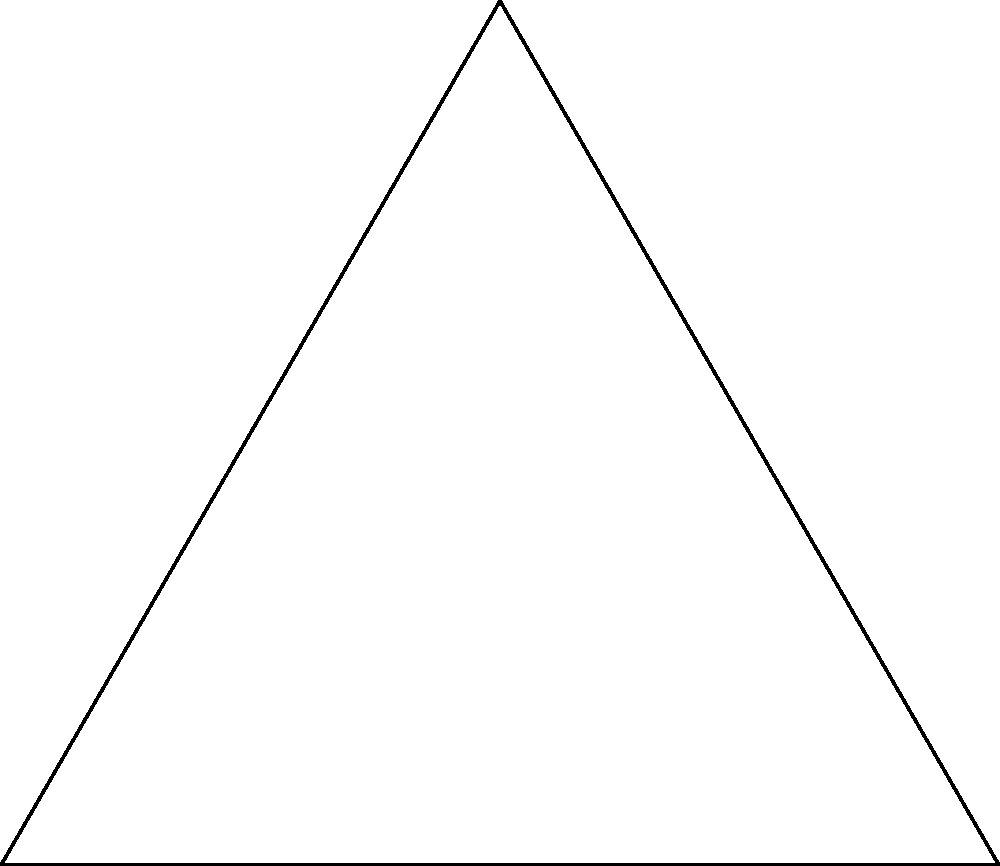In an aerial photograph of a historical Iranian airport, two runways intersect at point O. Runway 1 extends from O to A, and Runway 2 extends from O to B. If OA = 4 km, OB = 4 km, and AB = 4 km, what is the angle $\theta$ (in degrees) between the two runways? To find the angle between the two runways, we can use the cosine law. The cosine law states that in a triangle with sides a, b, and c, and an angle C opposite side c:

$$c^2 = a^2 + b^2 - 2ab \cos(C)$$

In our case:
OA = OB = 4 km (given)
AB = 4 km (given)
$\theta$ is the angle we want to find

Let's apply the cosine law:

$$AB^2 = OA^2 + OB^2 - 2(OA)(OB)\cos(\theta)$$

Substituting the known values:

$$4^2 = 4^2 + 4^2 - 2(4)(4)\cos(\theta)$$

Simplifying:

$$16 = 32 - 32\cos(\theta)$$

Subtracting 32 from both sides:

$$-16 = -32\cos(\theta)$$

Dividing both sides by -32:

$$\frac{1}{2} = \cos(\theta)$$

To find $\theta$, we need to take the inverse cosine (arccos) of both sides:

$$\theta = \arccos(\frac{1}{2})$$

Using a calculator or mathematical tables:

$$\theta \approx 60°$$

Therefore, the angle between the two runways is approximately 60 degrees.
Answer: 60° 